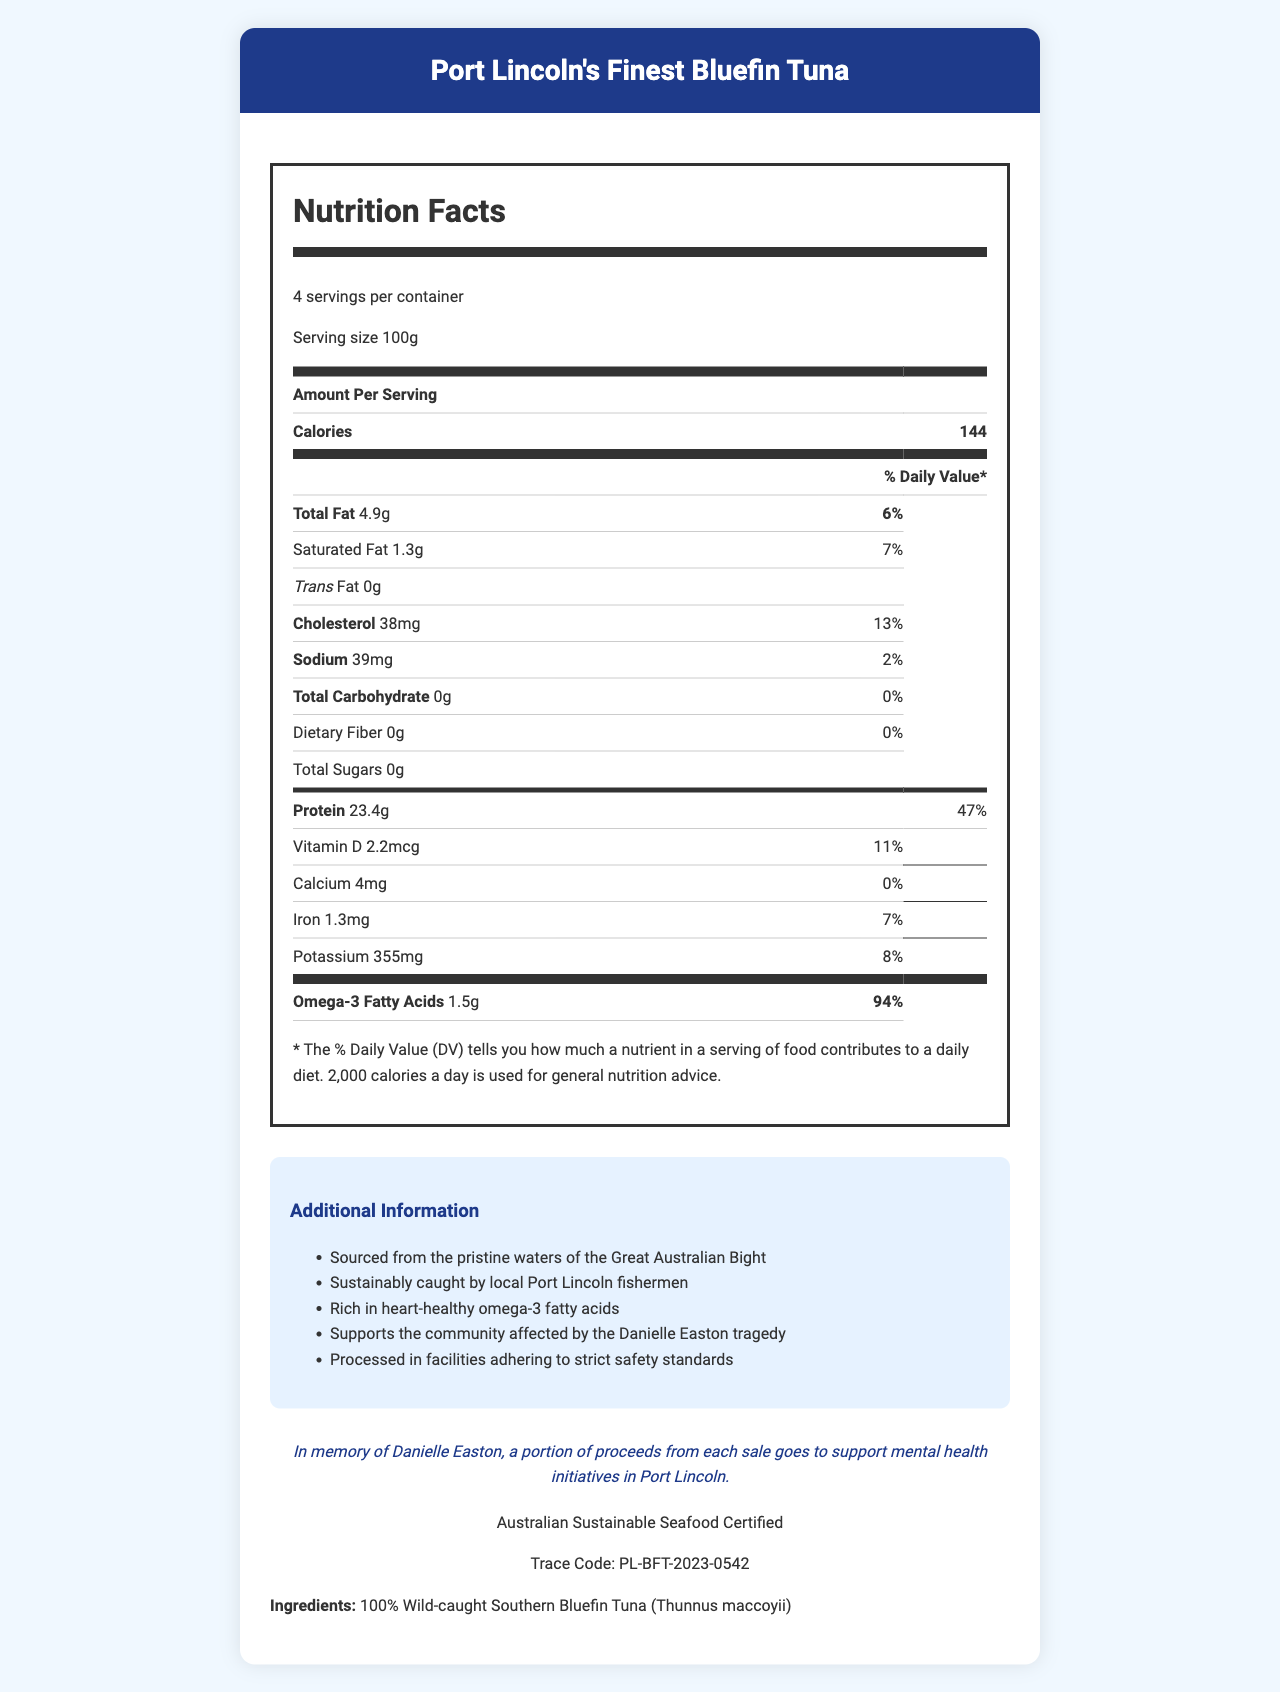what is the serving size of Port Lincoln's Finest Bluefin Tuna? The serving size is listed at the top of the nutrition facts section as "Serving size 100g".
Answer: 100g how many calories are in one serving? The nutrition facts section states "Calories 144" next to the amount per serving.
Answer: 144 what is the main source of omega-3 fatty acids in this product? The ingredients section lists "100% Wild-caught Southern Bluefin Tuna (Thunnus maccoyii)".
Answer: Wild-caught Southern Bluefin Tuna how many grams of protein are in one serving? The nutrition facts section states "Protein 23.4g".
Answer: 23.4g how much calcium does one serving contain? The nutrition facts section lists "Calcium 4mg".
Answer: 4mg how many servings are per container? A. 2 B. 3 C. 4 The number of servings is listed as "4 servings per container" at the top of the nutrition facts section.
Answer: C what is the daily value percentage for omega-3 fatty acids? A. 47% B. 94% C. 11% The daily value percentage for omega-3 fatty acids is listed as 94% in the nutrition facts section.
Answer: B is the product sustainably sourced? The additional information and certification sections state that the product is both sustainably caught and certified by the "Australian Sustainable Seafood Certified."
Answer: Yes are there any added sugars in this product? The total sugars amount is listed as "0g" indicating there are no added sugars.
Answer: No summarize the main idea of the document. The document outlines both the nutritional values and the ethical considerations of the product, emphasizing its health benefits and community impact.
Answer: The document provides the nutrition facts and additional information for Port Lincoln's Finest Bluefin Tuna, highlighting its health benefits, sustainable sourcing, and connection to the Port Lincoln community. It details the nutritional content per serving, including omega-3 fatty acids, and mentions the company's support for mental health initiatives in memory of Danielle Easton. where specifically is the tuna sourced from? The additional information section states that the tuna is sourced from the pristine waters of the Great Australian Bight.
Answer: The Great Australian Bight what is the trace code for the product? A. PL-BFT-2023-001 B. PL-BFT-2023-1234 C. PL-BFT-2023-0542 The certification section lists the trace code as "PL-BFT-2023-0542".
Answer: C how much cholesterol is in a serving? The nutrition facts section lists "Cholesterol 38mg".
Answer: 38mg how much sodium is in one serving? The nutrition facts section lists "Sodium 39mg".
Answer: 39mg what initiatives do proceeds from the product support? The company statement section mentions that a portion of proceeds goes to support mental health initiatives in Port Lincoln in memory of Danielle Easton.
Answer: Mental health initiatives in Port Lincoln what is the daily value percentage for saturated fat? The nutrition facts section lists "Saturated Fat 1.3g 7%".
Answer: 7% how much vitamin D is in one serving? The nutrition facts section lists "Vitamin D 2.2mcg".
Answer: 2.2mcg how much total carbohydrate does one serving contain? The nutrition facts section lists "Total Carbohydrate 0g".
Answer: 0g what is the processing standard for this product? The additional information section states that the product is processed in facilities adhering to strict safety standards.
Answer: Facilities adhering to strict safety standards what is the reason for the company’s support for mental health initiatives? The company statement section mentions that the support is in memory of Danielle Easton.
Answer: In memory of Danielle Easton how is the product connected to the community? The additional information and company statement sections highlight the community connection through sustainable fishing practices and support for local mental health initiatives.
Answer: The product is sustainably caught by local Port Lincoln fishermen and supports mental health initiatives are the fats in the product mostly trans fats? The nutrition facts section lists "Trans Fat 0g."
Answer: No what specific mental health initiatives are supported? The document mentions support for mental health initiatives but does not specify which initiatives.
Answer: Not enough information 